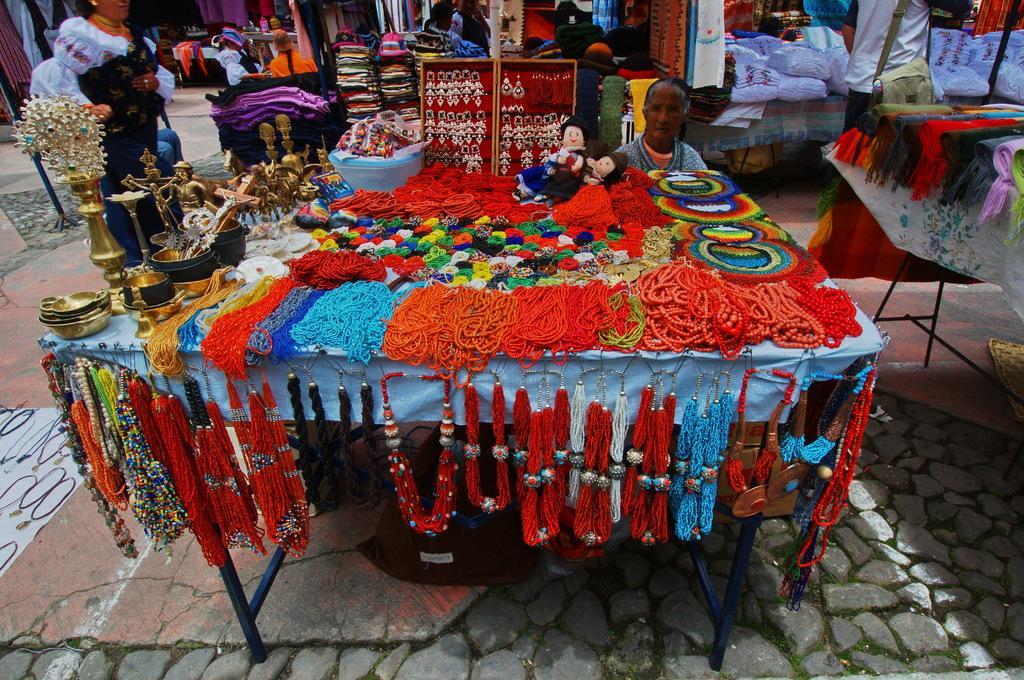Describe this image in one or two sentences. In this image there are tables and we can see accessories, statues, dolls,clothes and some objects placed on the tables. There is a stand and we can see earrings placed in the stand. On the left there is a lady. In the center we can see a lady sitting. At the bottom there is a floor and we can see chains. 